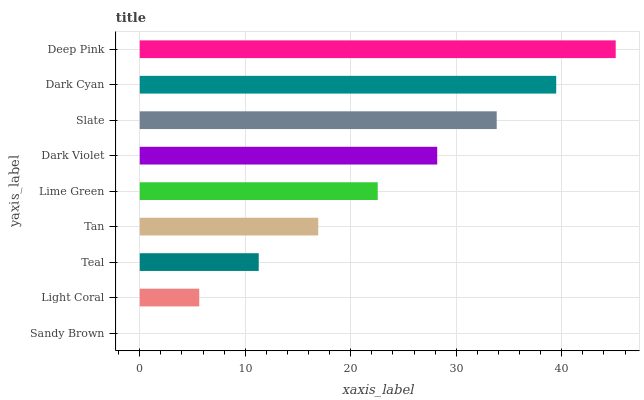Is Sandy Brown the minimum?
Answer yes or no. Yes. Is Deep Pink the maximum?
Answer yes or no. Yes. Is Light Coral the minimum?
Answer yes or no. No. Is Light Coral the maximum?
Answer yes or no. No. Is Light Coral greater than Sandy Brown?
Answer yes or no. Yes. Is Sandy Brown less than Light Coral?
Answer yes or no. Yes. Is Sandy Brown greater than Light Coral?
Answer yes or no. No. Is Light Coral less than Sandy Brown?
Answer yes or no. No. Is Lime Green the high median?
Answer yes or no. Yes. Is Lime Green the low median?
Answer yes or no. Yes. Is Light Coral the high median?
Answer yes or no. No. Is Slate the low median?
Answer yes or no. No. 